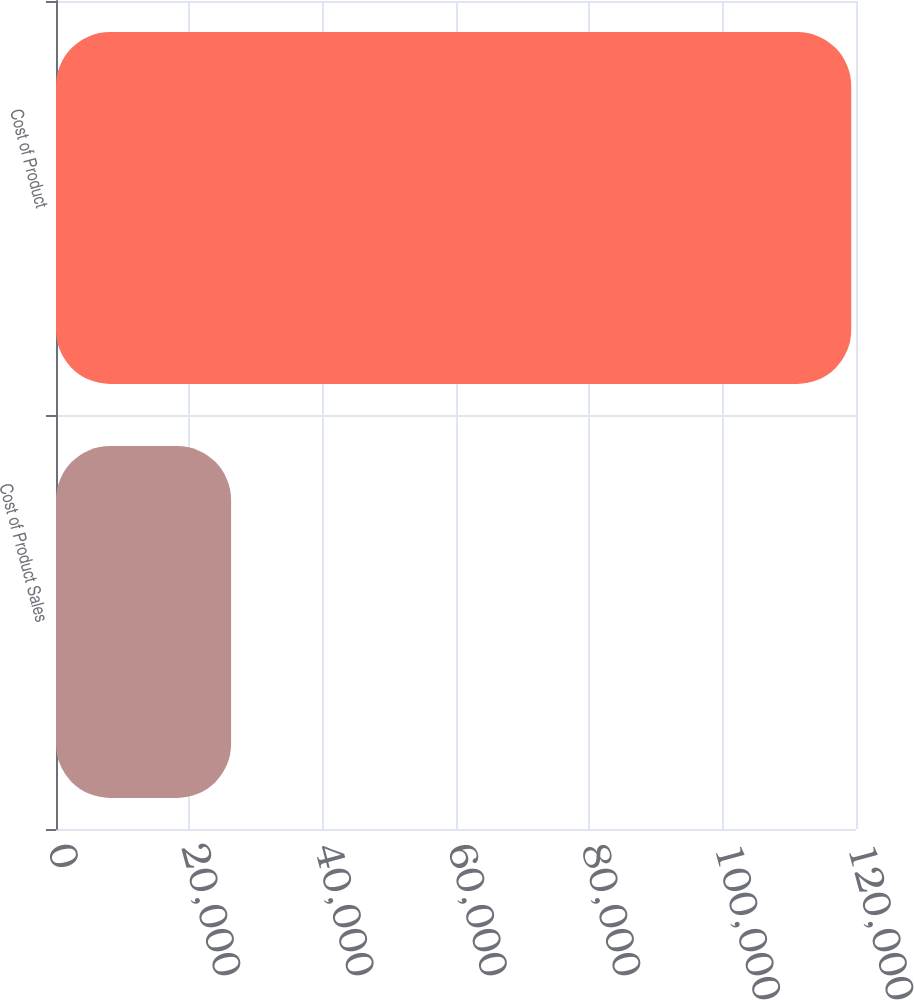Convert chart. <chart><loc_0><loc_0><loc_500><loc_500><bar_chart><fcel>Cost of Product Sales<fcel>Cost of Product<nl><fcel>26263.7<fcel>119285<nl></chart> 